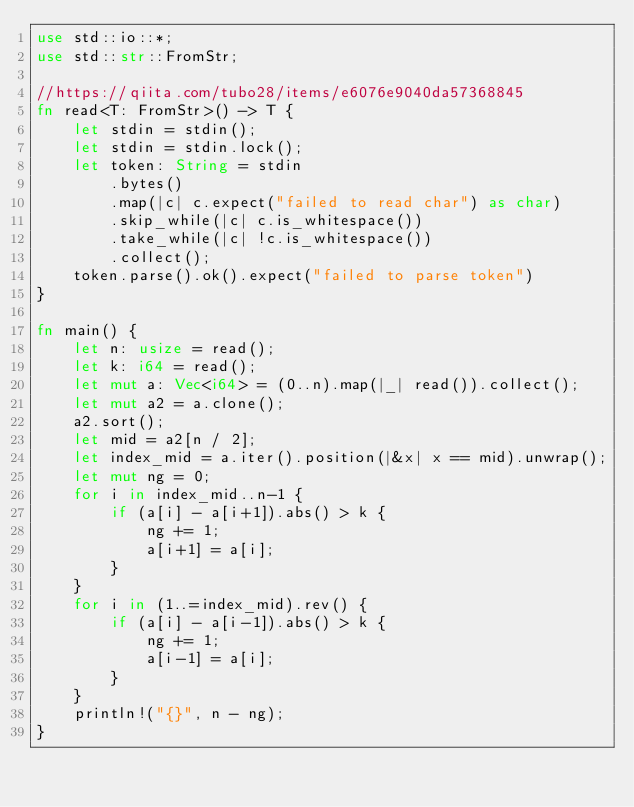Convert code to text. <code><loc_0><loc_0><loc_500><loc_500><_Rust_>use std::io::*;
use std::str::FromStr;

//https://qiita.com/tubo28/items/e6076e9040da57368845
fn read<T: FromStr>() -> T {
    let stdin = stdin();
    let stdin = stdin.lock();
    let token: String = stdin
        .bytes()
        .map(|c| c.expect("failed to read char") as char)
        .skip_while(|c| c.is_whitespace())
        .take_while(|c| !c.is_whitespace())
        .collect();
    token.parse().ok().expect("failed to parse token")
}

fn main() {
    let n: usize = read();
    let k: i64 = read();
    let mut a: Vec<i64> = (0..n).map(|_| read()).collect();
    let mut a2 = a.clone();
    a2.sort();
    let mid = a2[n / 2];
    let index_mid = a.iter().position(|&x| x == mid).unwrap();
    let mut ng = 0;
    for i in index_mid..n-1 {
        if (a[i] - a[i+1]).abs() > k {
            ng += 1;
            a[i+1] = a[i];
        }
    }
    for i in (1..=index_mid).rev() {
        if (a[i] - a[i-1]).abs() > k {
            ng += 1;
            a[i-1] = a[i];
        }
    }
    println!("{}", n - ng);
}
</code> 